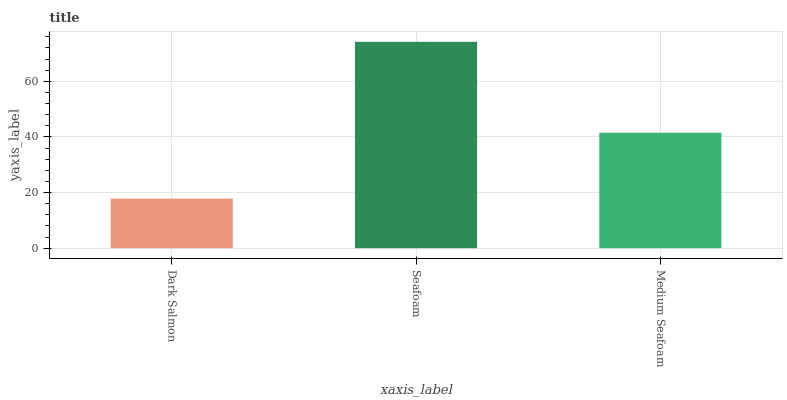Is Dark Salmon the minimum?
Answer yes or no. Yes. Is Seafoam the maximum?
Answer yes or no. Yes. Is Medium Seafoam the minimum?
Answer yes or no. No. Is Medium Seafoam the maximum?
Answer yes or no. No. Is Seafoam greater than Medium Seafoam?
Answer yes or no. Yes. Is Medium Seafoam less than Seafoam?
Answer yes or no. Yes. Is Medium Seafoam greater than Seafoam?
Answer yes or no. No. Is Seafoam less than Medium Seafoam?
Answer yes or no. No. Is Medium Seafoam the high median?
Answer yes or no. Yes. Is Medium Seafoam the low median?
Answer yes or no. Yes. Is Dark Salmon the high median?
Answer yes or no. No. Is Seafoam the low median?
Answer yes or no. No. 